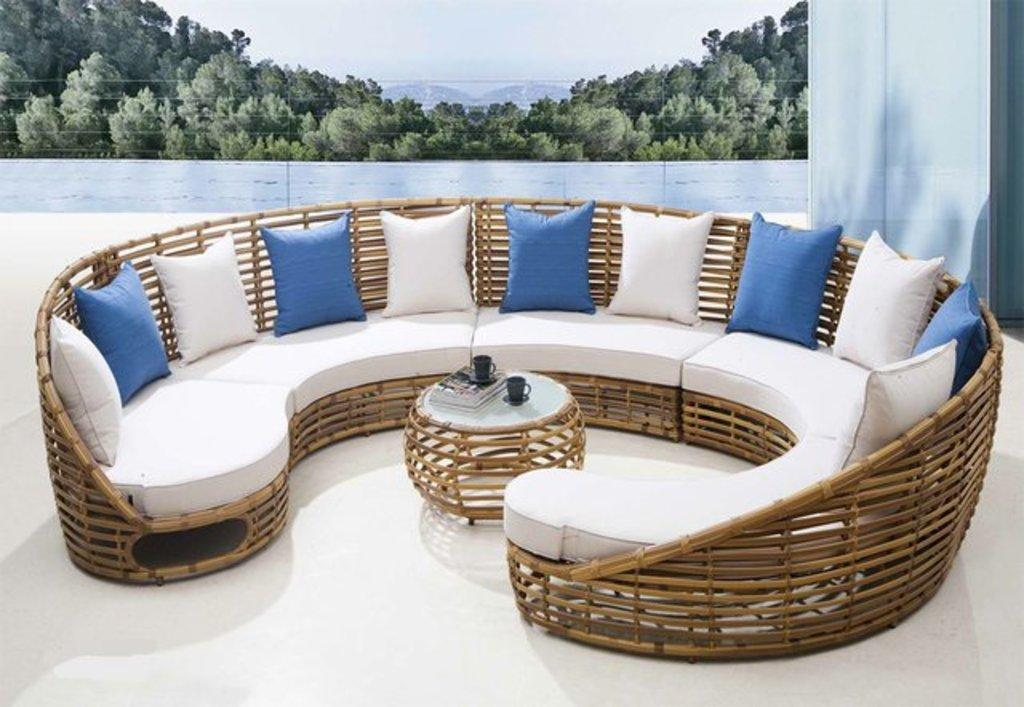What type of furniture is in the image? There is a sofa in the image. What is on the sofa? There are pillows on the sofa. What other piece of furniture is in the image? There is a table in the image. What is on the table? There are books and cups on the table. What can be seen on the floor in the image? There is no specific detail about the floor mentioned in the facts. What is visible in the background of the image? There are trees, sky, and a wall visible in the background. What type of bread is being used as a loaf in the image? There is no loaf of bread present in the image. What hobbies are the people in the image engaged in? The facts provided do not mention any people in the image, so we cannot determine their hobbies. 